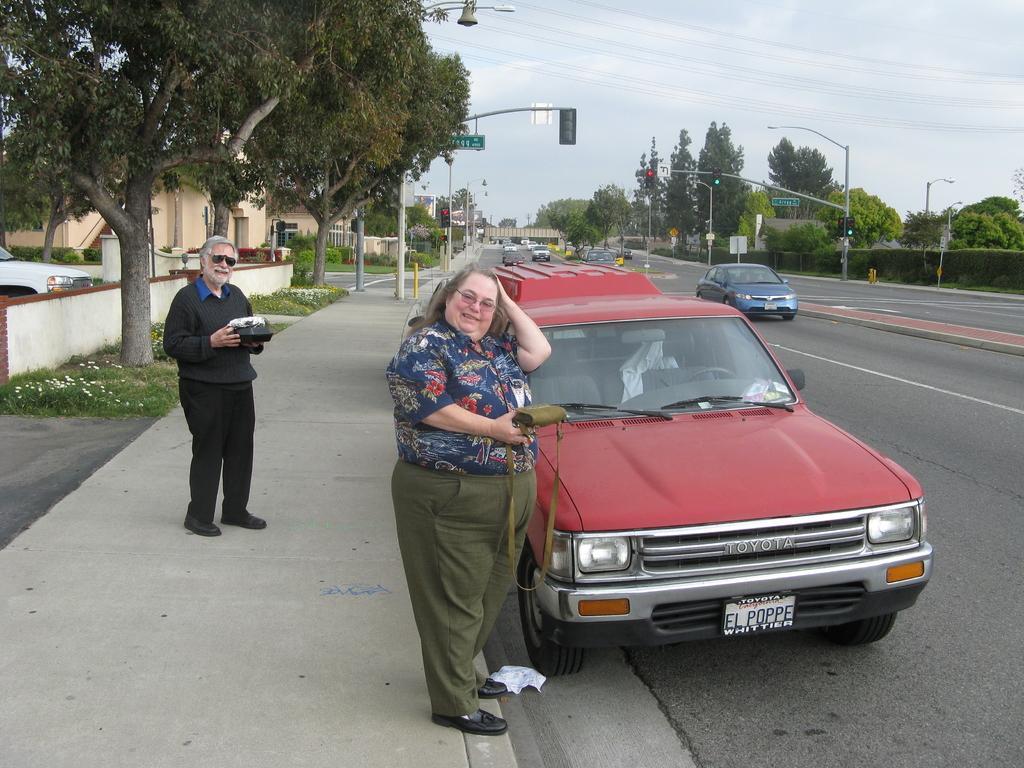How would you summarize this image in a sentence or two? In this picture we can see a woman holding a bag and standing on the path. Few vehicles are visible on the road. There is a person holding an object standing on the path. We can see street lights, some boards on the poles and a traffic signal on the path. Sky is cloudy. 